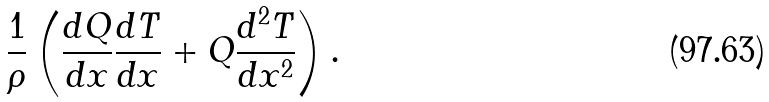Convert formula to latex. <formula><loc_0><loc_0><loc_500><loc_500>\frac { 1 } { \rho } \left ( \frac { d Q } { d x } \frac { d T } { d x } + Q \frac { d ^ { 2 } T } { d x ^ { 2 } } \right ) .</formula> 